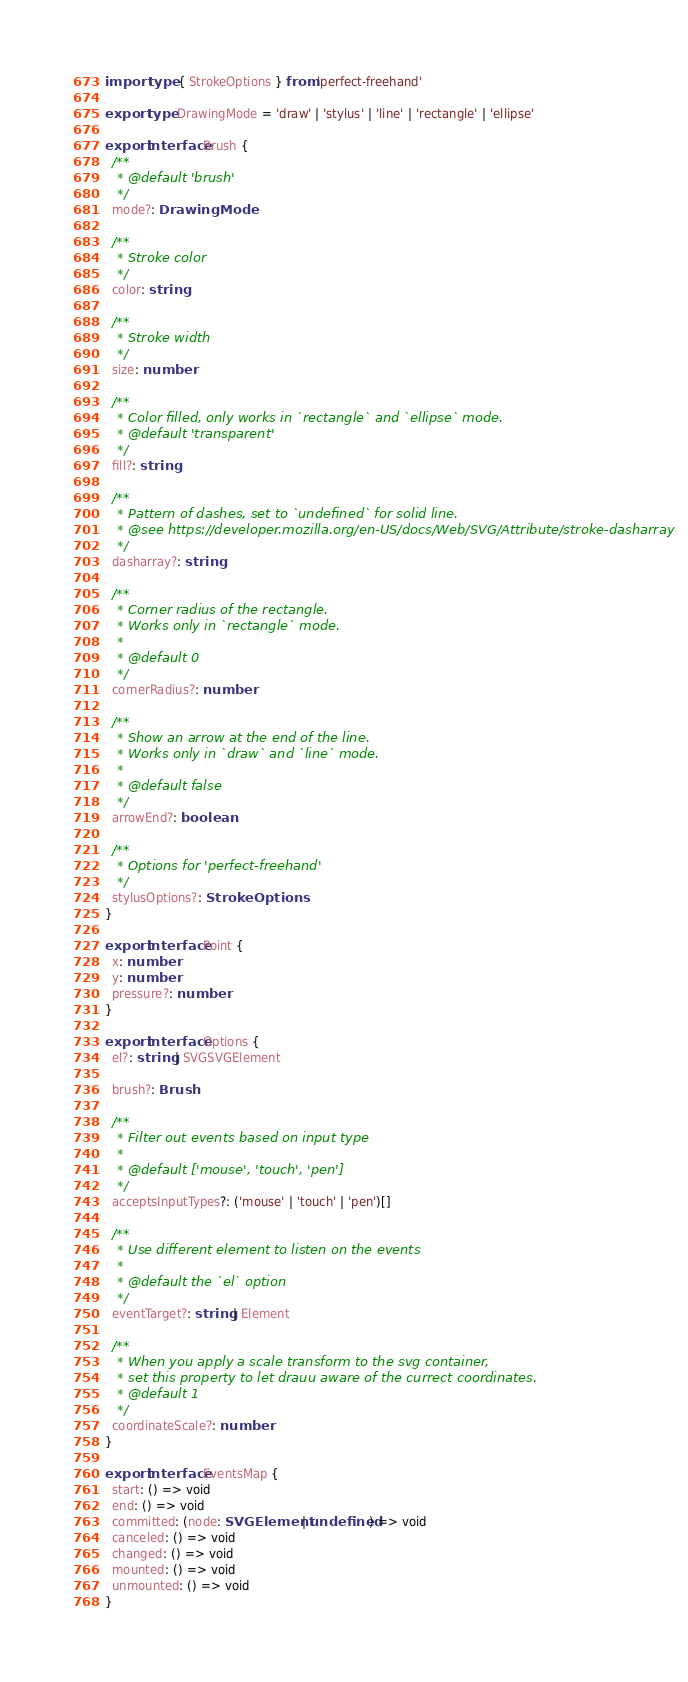<code> <loc_0><loc_0><loc_500><loc_500><_TypeScript_>import type { StrokeOptions } from 'perfect-freehand'

export type DrawingMode = 'draw' | 'stylus' | 'line' | 'rectangle' | 'ellipse'

export interface Brush {
  /**
   * @default 'brush'
   */
  mode?: DrawingMode

  /**
   * Stroke color
   */
  color: string

  /**
   * Stroke width
   */
  size: number

  /**
   * Color filled, only works in `rectangle` and `ellipse` mode.
   * @default 'transparent'
   */
  fill?: string

  /**
   * Pattern of dashes, set to `undefined` for solid line.
   * @see https://developer.mozilla.org/en-US/docs/Web/SVG/Attribute/stroke-dasharray
   */
  dasharray?: string

  /**
   * Corner radius of the rectangle.
   * Works only in `rectangle` mode.
   *
   * @default 0
   */
  cornerRadius?: number

  /**
   * Show an arrow at the end of the line.
   * Works only in `draw` and `line` mode.
   *
   * @default false
   */
  arrowEnd?: boolean

  /**
   * Options for 'perfect-freehand'
   */
  stylusOptions?: StrokeOptions
}

export interface Point {
  x: number
  y: number
  pressure?: number
}

export interface Options {
  el?: string | SVGSVGElement

  brush?: Brush

  /**
   * Filter out events based on input type
   *
   * @default ['mouse', 'touch', 'pen']
   */
  acceptsInputTypes?: ('mouse' | 'touch' | 'pen')[]

  /**
   * Use different element to listen on the events
   *
   * @default the `el` option
   */
  eventTarget?: string | Element

  /**
   * When you apply a scale transform to the svg container,
   * set this property to let drauu aware of the currect coordinates.
   * @default 1
   */
  coordinateScale?: number
}

export interface EventsMap {
  start: () => void
  end: () => void
  committed: (node: SVGElement | undefined) => void
  canceled: () => void
  changed: () => void
  mounted: () => void
  unmounted: () => void
}
</code> 